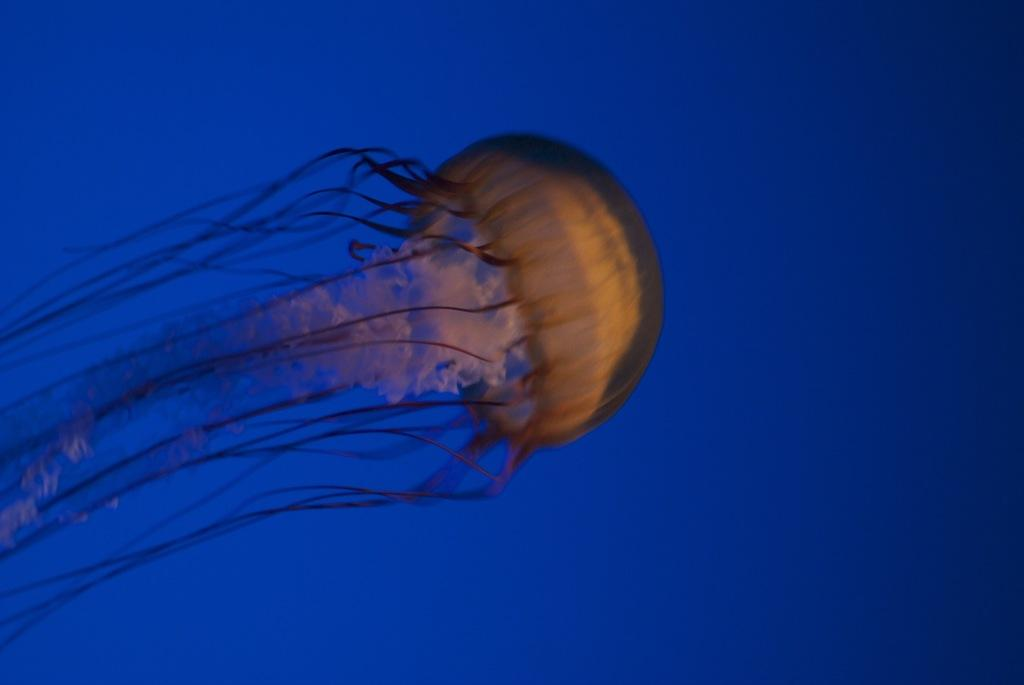What is the main subject of the picture? There is a jellyfish in the picture. What color is the background of the picture? The background of the picture is blue. What type of haircut does the jellyfish have in the picture? The jellyfish does not have a haircut, as it is a marine animal without hair. What is the jellyfish discussing with other creatures in the picture? There are no other creatures present in the picture, and therefore no discussion can be observed. 